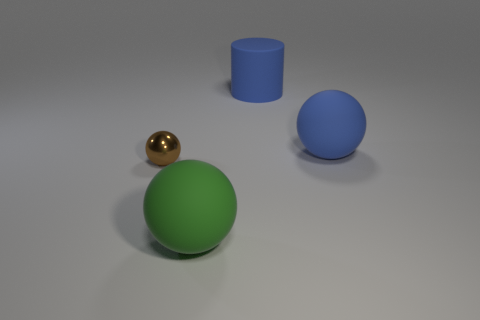Do the big ball that is behind the tiny brown metallic sphere and the thing that is behind the blue rubber ball have the same color?
Your response must be concise. Yes. Are there any green rubber spheres on the left side of the large green sphere?
Offer a terse response. No. What is the large object that is in front of the big blue cylinder and behind the tiny metallic thing made of?
Your response must be concise. Rubber. Do the green thing that is on the left side of the large rubber cylinder and the small brown thing have the same material?
Your answer should be very brief. No. What material is the large cylinder?
Make the answer very short. Rubber. What size is the sphere to the right of the green matte object?
Keep it short and to the point. Large. Is there anything else that is the same color as the small shiny object?
Provide a short and direct response. No. There is a matte sphere that is left of the matte sphere that is behind the brown ball; are there any matte spheres that are to the left of it?
Your answer should be very brief. No. There is a big sphere behind the tiny thing; is its color the same as the tiny metal ball?
Give a very brief answer. No. What number of cubes are metallic things or small purple shiny objects?
Keep it short and to the point. 0. 